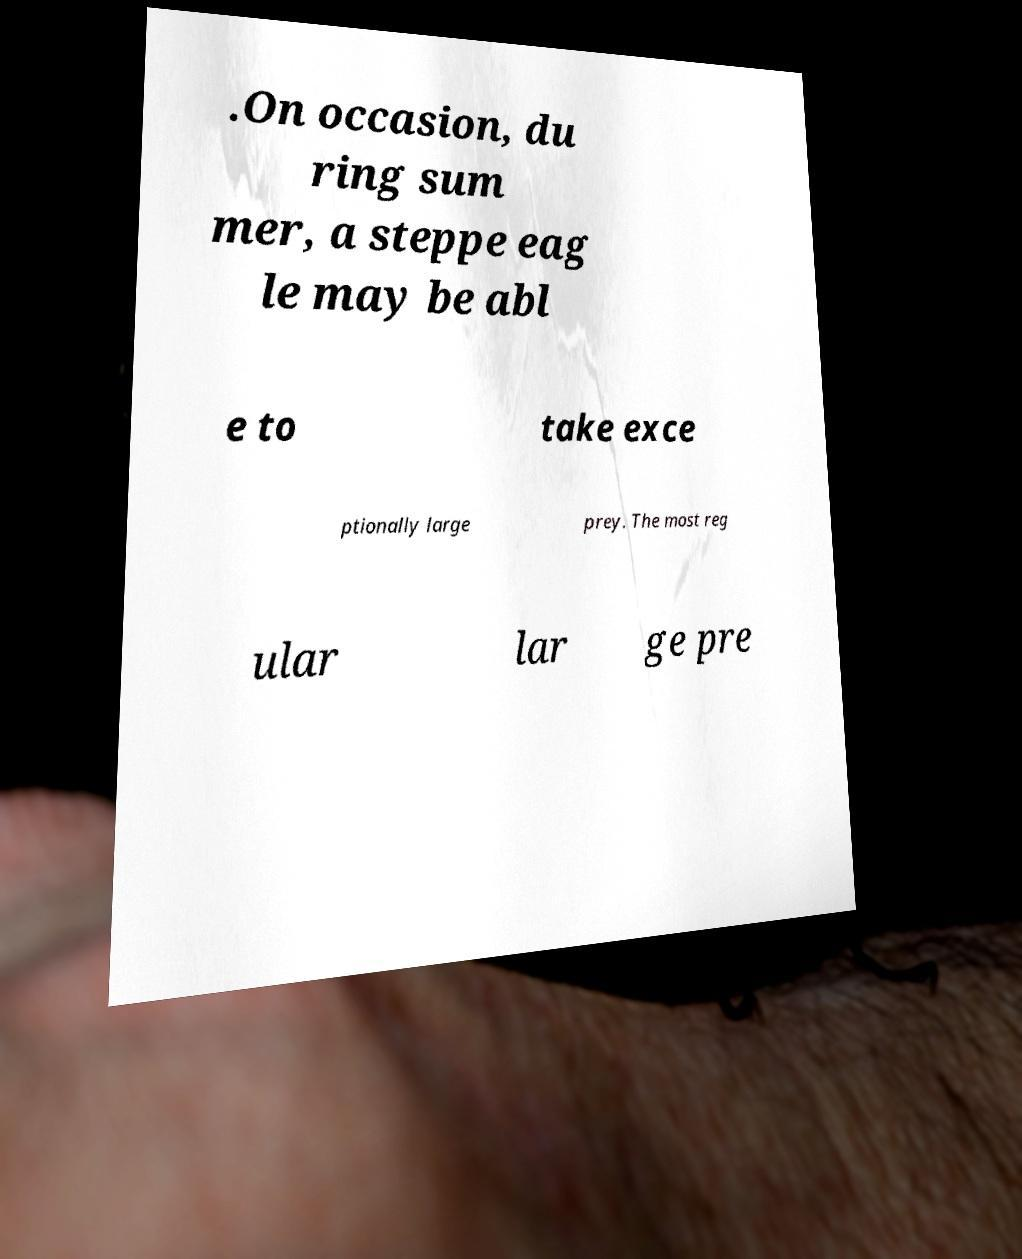What messages or text are displayed in this image? I need them in a readable, typed format. .On occasion, du ring sum mer, a steppe eag le may be abl e to take exce ptionally large prey. The most reg ular lar ge pre 